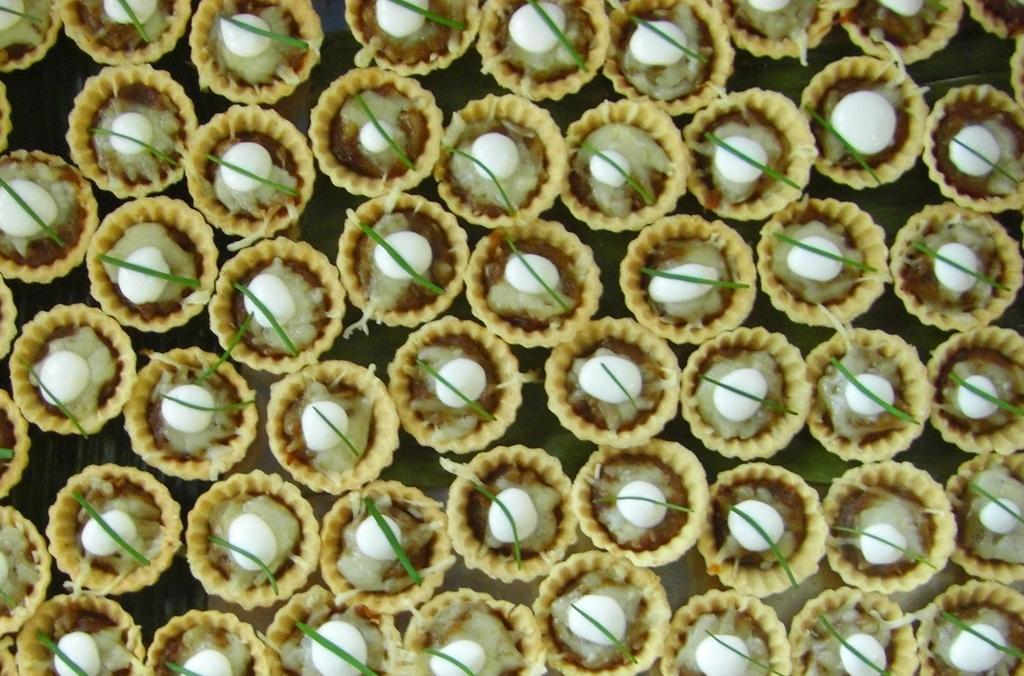How would you summarize this image in a sentence or two? In this image, we can see so many tartlets with some sauce and eatable things. 